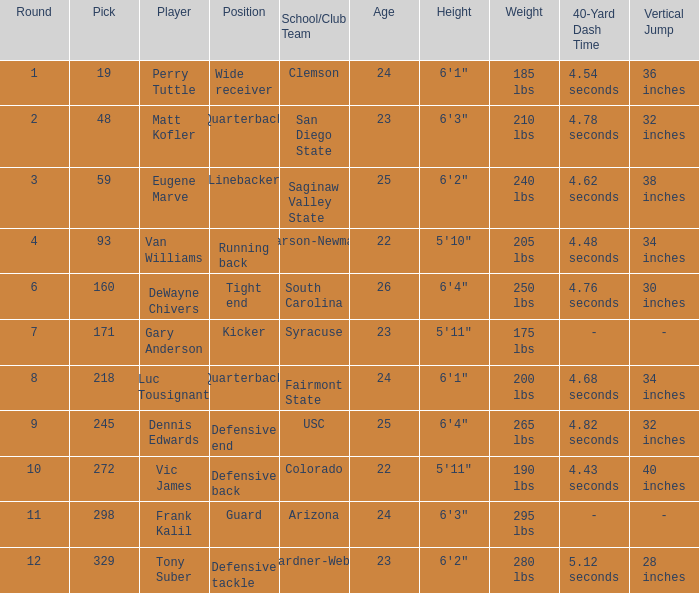Which player's pick is 160? DeWayne Chivers. 